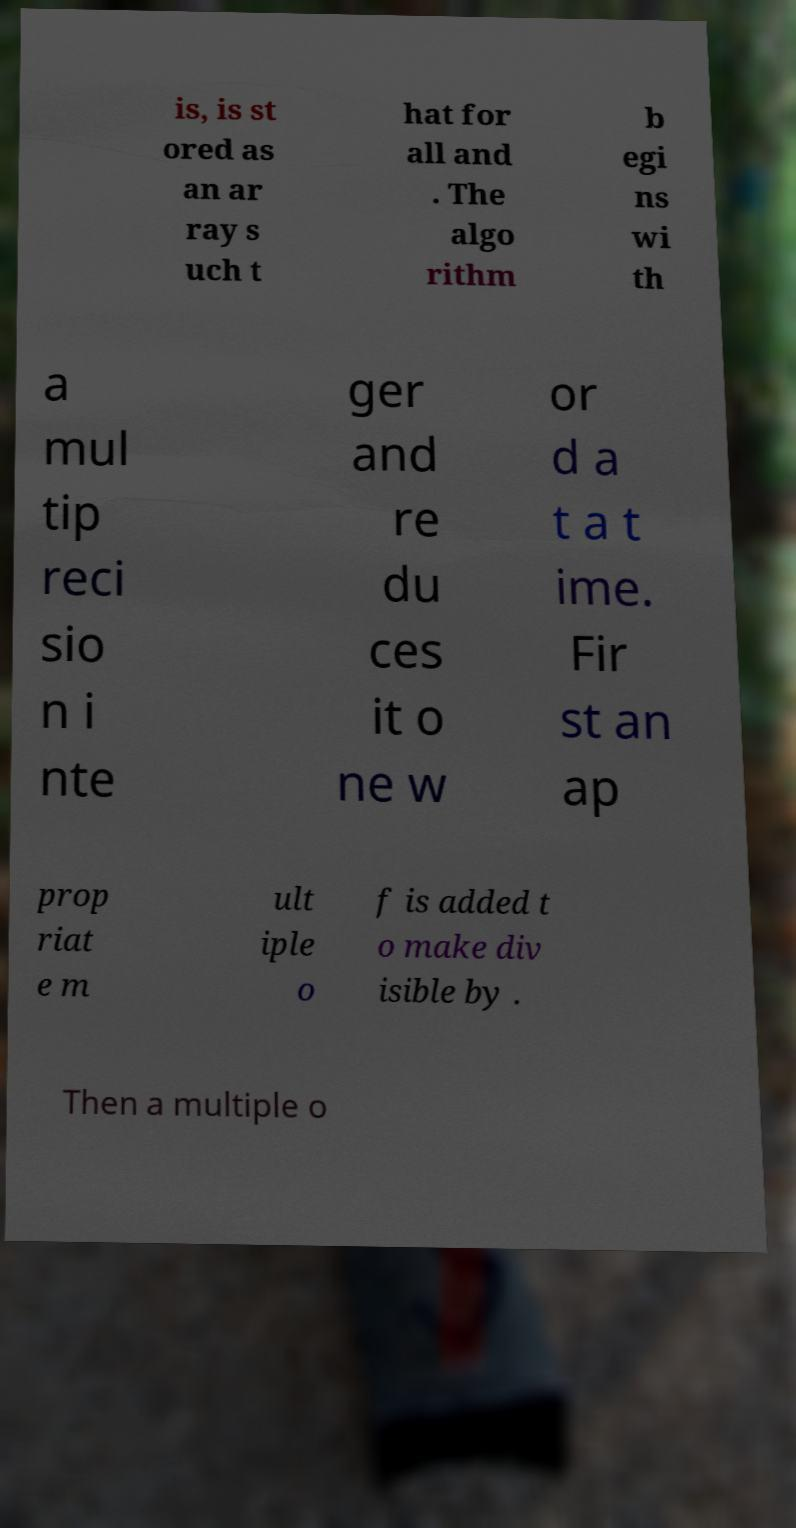Can you read and provide the text displayed in the image?This photo seems to have some interesting text. Can you extract and type it out for me? is, is st ored as an ar ray s uch t hat for all and . The algo rithm b egi ns wi th a mul tip reci sio n i nte ger and re du ces it o ne w or d a t a t ime. Fir st an ap prop riat e m ult iple o f is added t o make div isible by . Then a multiple o 